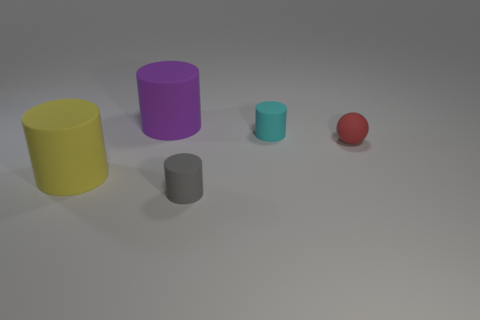Can you tell me the colors of the cylinders in the image? Certainly! There are three cylinders, each with a distinct color. One is yellow, the second is purple, and the third one appears to be a shade of gray. 